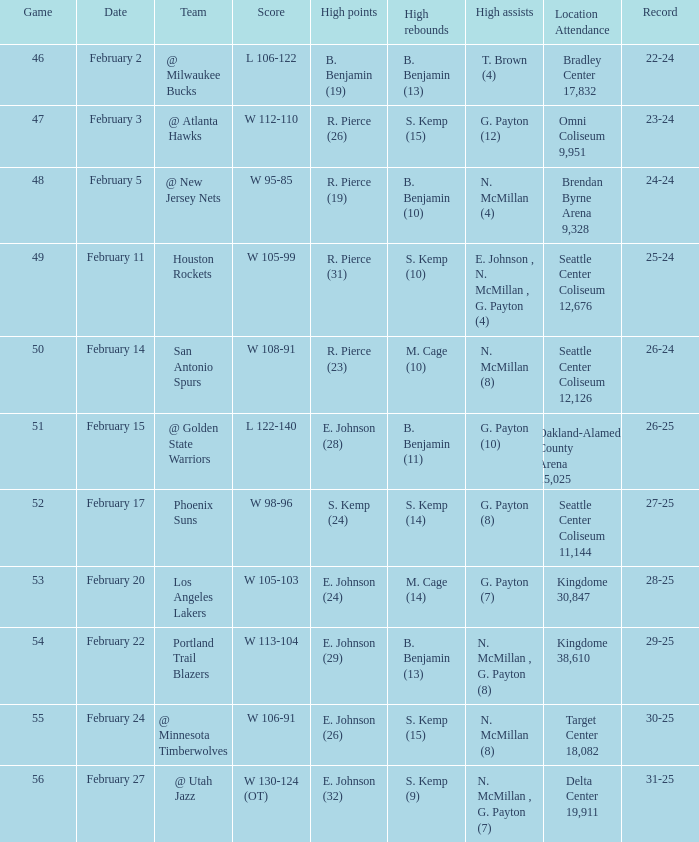Which game had a score of w 95-85? 48.0. Can you give me this table as a dict? {'header': ['Game', 'Date', 'Team', 'Score', 'High points', 'High rebounds', 'High assists', 'Location Attendance', 'Record'], 'rows': [['46', 'February 2', '@ Milwaukee Bucks', 'L 106-122', 'B. Benjamin (19)', 'B. Benjamin (13)', 'T. Brown (4)', 'Bradley Center 17,832', '22-24'], ['47', 'February 3', '@ Atlanta Hawks', 'W 112-110', 'R. Pierce (26)', 'S. Kemp (15)', 'G. Payton (12)', 'Omni Coliseum 9,951', '23-24'], ['48', 'February 5', '@ New Jersey Nets', 'W 95-85', 'R. Pierce (19)', 'B. Benjamin (10)', 'N. McMillan (4)', 'Brendan Byrne Arena 9,328', '24-24'], ['49', 'February 11', 'Houston Rockets', 'W 105-99', 'R. Pierce (31)', 'S. Kemp (10)', 'E. Johnson , N. McMillan , G. Payton (4)', 'Seattle Center Coliseum 12,676', '25-24'], ['50', 'February 14', 'San Antonio Spurs', 'W 108-91', 'R. Pierce (23)', 'M. Cage (10)', 'N. McMillan (8)', 'Seattle Center Coliseum 12,126', '26-24'], ['51', 'February 15', '@ Golden State Warriors', 'L 122-140', 'E. Johnson (28)', 'B. Benjamin (11)', 'G. Payton (10)', 'Oakland-Alameda County Arena 15,025', '26-25'], ['52', 'February 17', 'Phoenix Suns', 'W 98-96', 'S. Kemp (24)', 'S. Kemp (14)', 'G. Payton (8)', 'Seattle Center Coliseum 11,144', '27-25'], ['53', 'February 20', 'Los Angeles Lakers', 'W 105-103', 'E. Johnson (24)', 'M. Cage (14)', 'G. Payton (7)', 'Kingdome 30,847', '28-25'], ['54', 'February 22', 'Portland Trail Blazers', 'W 113-104', 'E. Johnson (29)', 'B. Benjamin (13)', 'N. McMillan , G. Payton (8)', 'Kingdome 38,610', '29-25'], ['55', 'February 24', '@ Minnesota Timberwolves', 'W 106-91', 'E. Johnson (26)', 'S. Kemp (15)', 'N. McMillan (8)', 'Target Center 18,082', '30-25'], ['56', 'February 27', '@ Utah Jazz', 'W 130-124 (OT)', 'E. Johnson (32)', 'S. Kemp (9)', 'N. McMillan , G. Payton (7)', 'Delta Center 19,911', '31-25']]} 